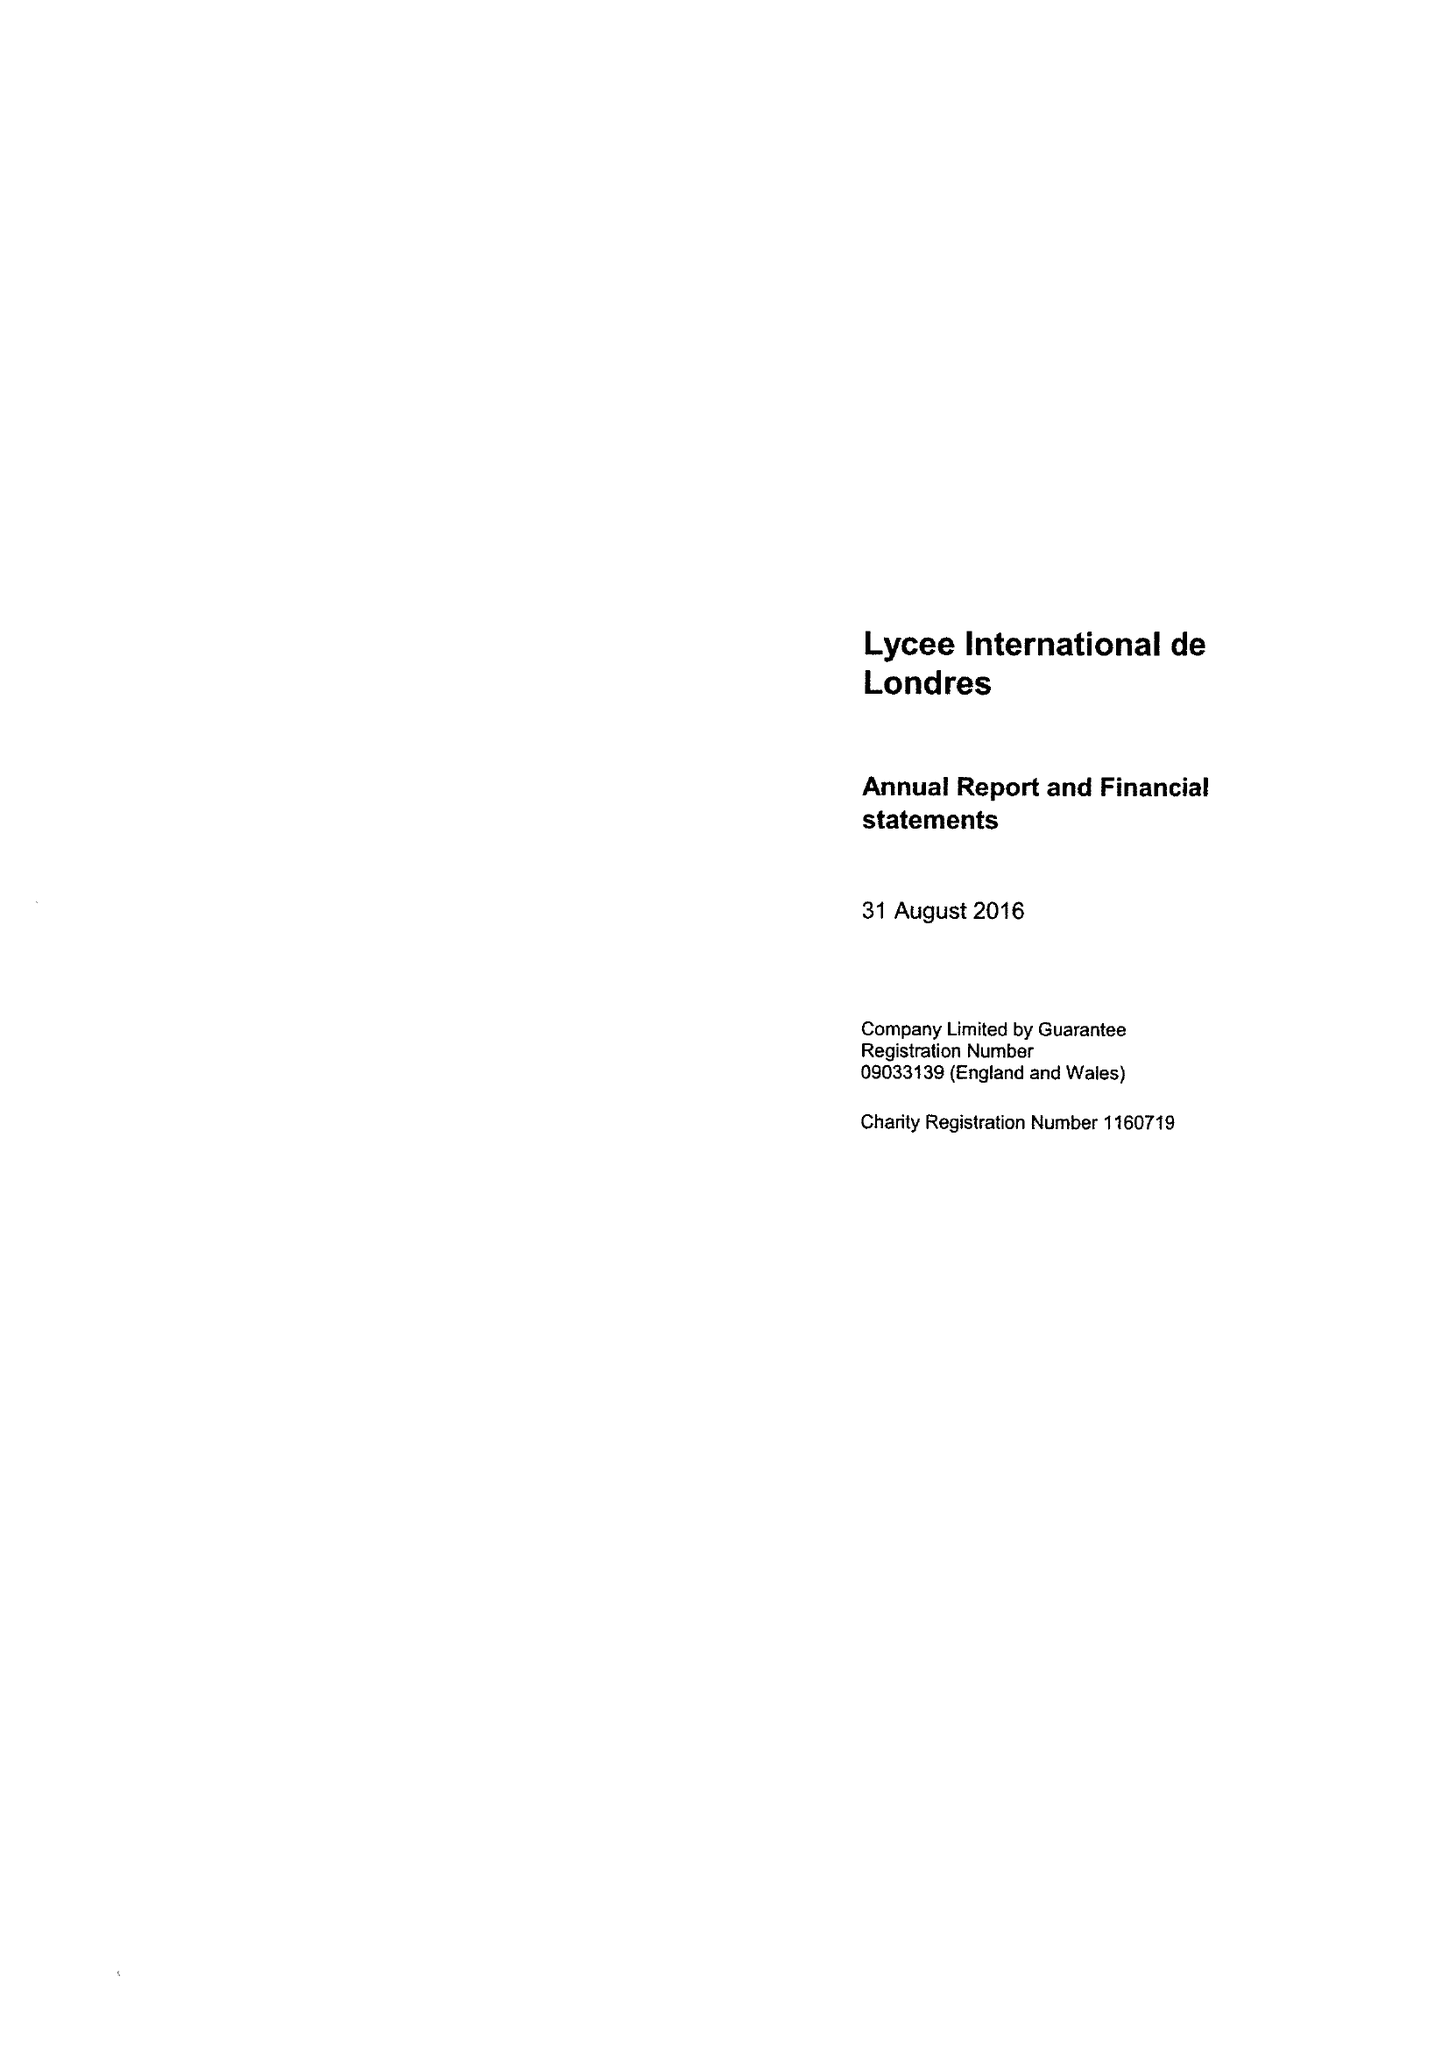What is the value for the address__post_town?
Answer the question using a single word or phrase. WEMBLEY 